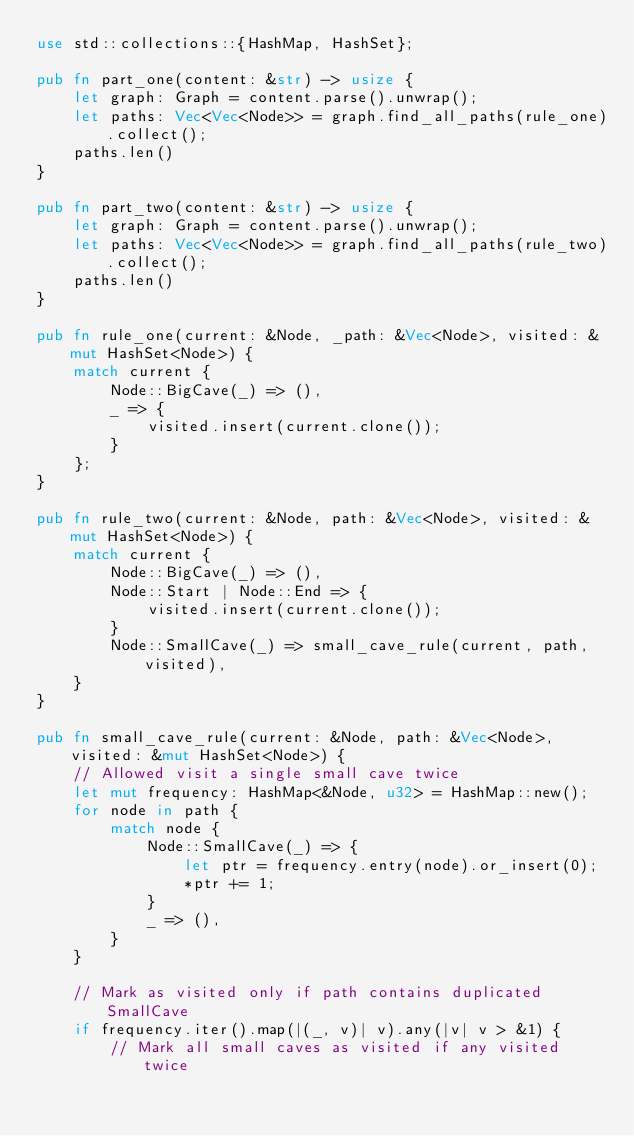Convert code to text. <code><loc_0><loc_0><loc_500><loc_500><_Rust_>use std::collections::{HashMap, HashSet};

pub fn part_one(content: &str) -> usize {
    let graph: Graph = content.parse().unwrap();
    let paths: Vec<Vec<Node>> = graph.find_all_paths(rule_one).collect();
    paths.len()
}

pub fn part_two(content: &str) -> usize {
    let graph: Graph = content.parse().unwrap();
    let paths: Vec<Vec<Node>> = graph.find_all_paths(rule_two).collect();
    paths.len()
}

pub fn rule_one(current: &Node, _path: &Vec<Node>, visited: &mut HashSet<Node>) {
    match current {
        Node::BigCave(_) => (),
        _ => {
            visited.insert(current.clone());
        }
    };
}

pub fn rule_two(current: &Node, path: &Vec<Node>, visited: &mut HashSet<Node>) {
    match current {
        Node::BigCave(_) => (),
        Node::Start | Node::End => {
            visited.insert(current.clone());
        }
        Node::SmallCave(_) => small_cave_rule(current, path, visited),
    }
}

pub fn small_cave_rule(current: &Node, path: &Vec<Node>, visited: &mut HashSet<Node>) {
    // Allowed visit a single small cave twice
    let mut frequency: HashMap<&Node, u32> = HashMap::new();
    for node in path {
        match node {
            Node::SmallCave(_) => {
                let ptr = frequency.entry(node).or_insert(0);
                *ptr += 1;
            }
            _ => (),
        }
    }

    // Mark as visited only if path contains duplicated SmallCave
    if frequency.iter().map(|(_, v)| v).any(|v| v > &1) {
        // Mark all small caves as visited if any visited twice</code> 